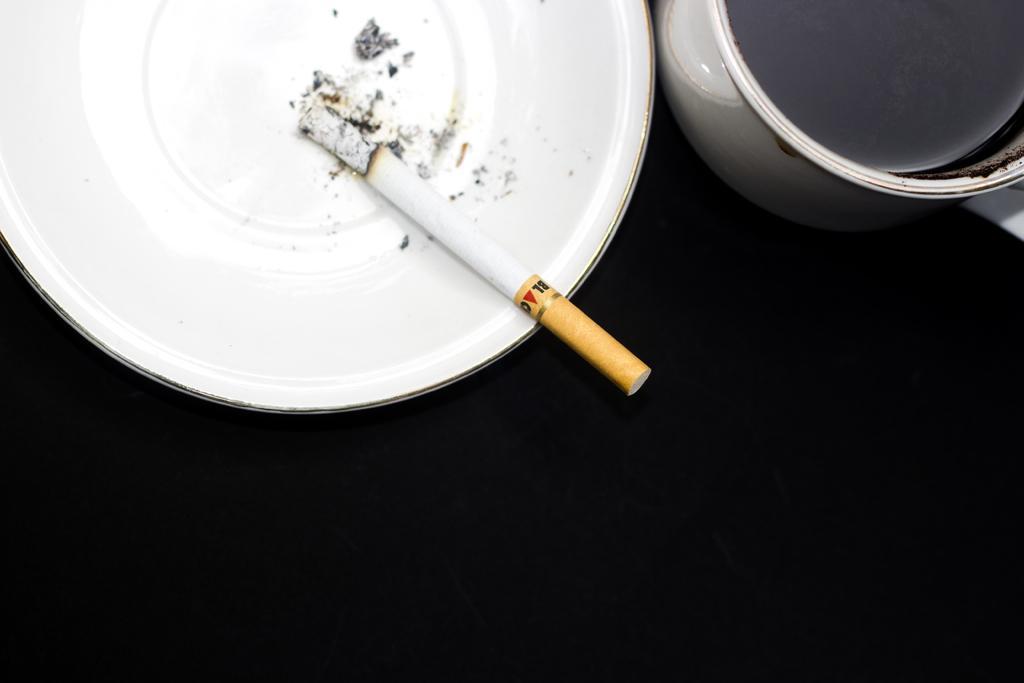In one or two sentences, can you explain what this image depicts? In this image we can see a cigarette which is in white color ceramic plate and there is coffee cup on the black surface. 